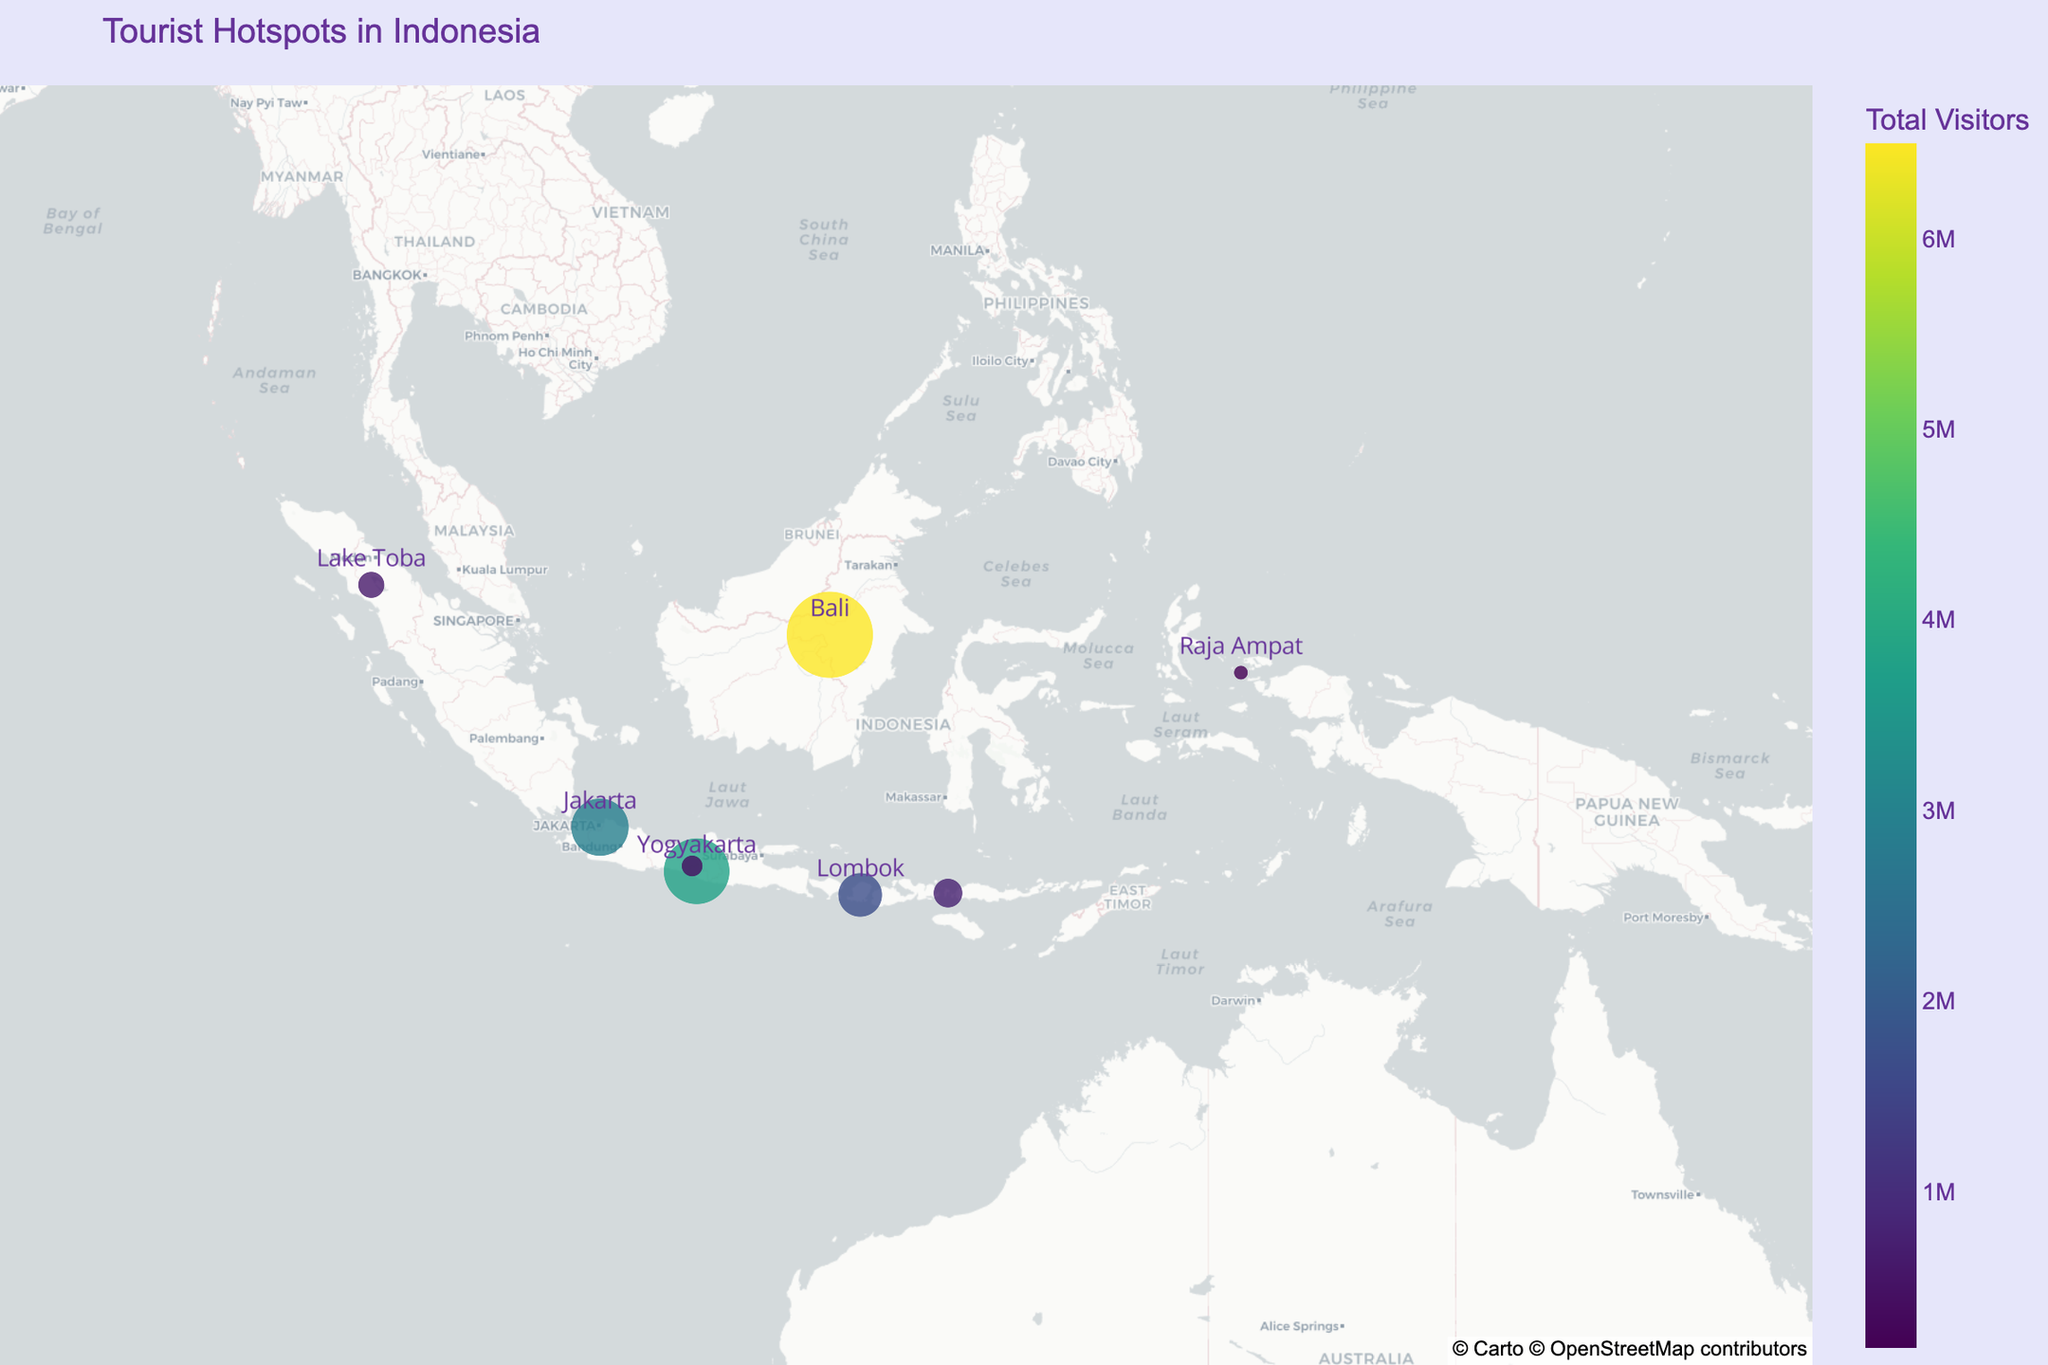what is the location with the most visitors? The figure legend shows the color scale for the total visitors, and we can see that Bali has the largest circle and the highest coloration, indicating it has the most visitors at 6,500,000
Answer: Bali Which locations have more visitors: Lombok or Raja Ampat? Comparing the sizes of the circles on the map, Lombok has a larger circle compared to Raja Ampat, indicating Lombok has more visitors. According to the data, Lombok has 1,700,000 visitors while Raja Ampat has 180,000
Answer: Lombok What are the top three countries of origin for visitors to Yogyakarta? Hovering over Yogyakarta on the map provides a tooltip revealing the top three countries of origin for visitors, which are the Netherlands, Germany, and France
Answer: Netherlands, Germany, France Which tourist hotspot has the least visitors and what are its top three countries of origin? By examining the circles on the map, we see that Raja Ampat has the smallest circle, indicating it has the least number of visitors. The hover text indicates its top three countries of origin are the United States, Australia, and the United Kingdom
Answer: Raja Ampat; United States, Australia, United Kingdom How does the total visitor count for Jakarta compare to Komodo Island? The circle for Jakarta is larger than that for Komodo Island, indicating more visitors. Jakarta has 2,900,000 visitors whereas Komodo Island has 750,000
Answer: Jakarta has more visitors What is the combined number of visitors for Bali and Lake Toba? According to the data, Bali has 6,500,000 visitors and Lake Toba has 620,000 visitors. Their combined number is 6,500,000 + 620,000 = 7,120,000
Answer: 7,120,000 Which places have Singapore as one of the top three countries of origin for visitors? From the hover text, the places where Singapore is one of the top three origins are Jakarta (Singapore is second), and Lake Toba (Singapore is the second)
Answer: Jakarta, Lake Toba What is the average number of visitors across all locations? Summing up the total number of visitors across all locations (6,500,000 + 3,800,000 + 2,900,000 + 1,700,000 + 750,000 + 620,000 + 400,000 + 180,000) = 16,850,000. There are 8 locations, so the average is 16,850,000 / 8 = 2,106,250
Answer: 2,106,250 